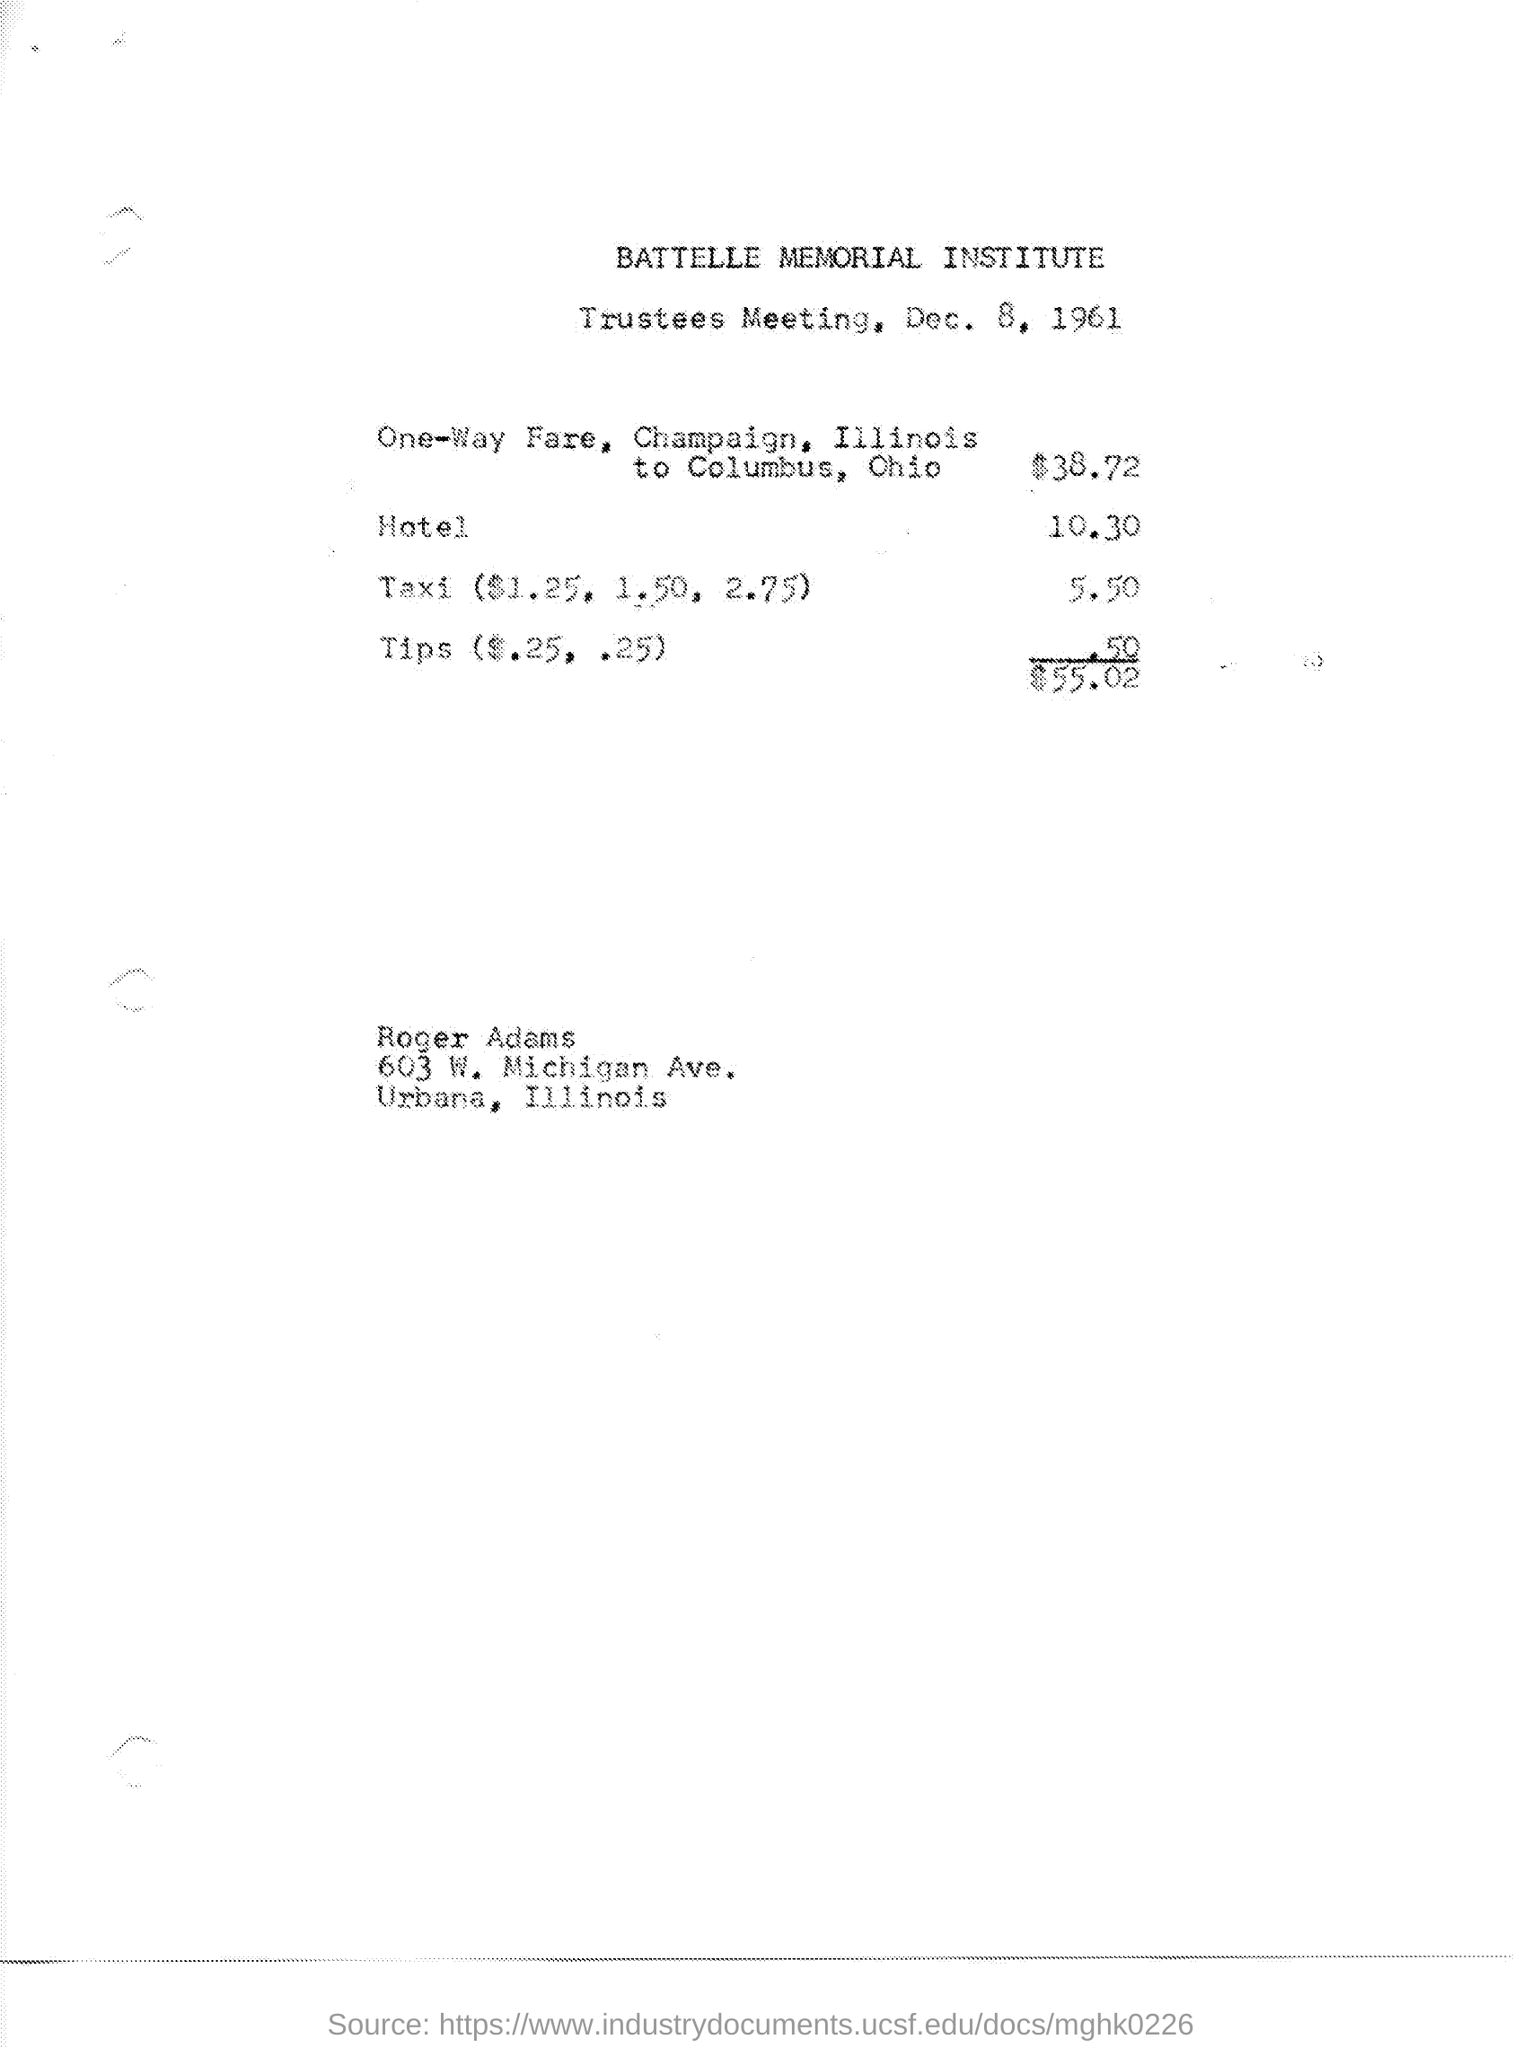Which institute is mentioned at the top of the page?
Give a very brief answer. BATTELLE MEMORIAL INSTITUTE. What is the meeting about?
Ensure brevity in your answer.  Trustees meeting. When is the meeting going to be held?
Provide a succinct answer. Dec. 8, 1961. What is the hotel fare in dollars?
Make the answer very short. 10.30. What is the total expense?
Ensure brevity in your answer.  $55.02. 